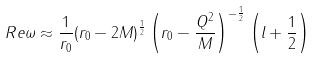Convert formula to latex. <formula><loc_0><loc_0><loc_500><loc_500>R e \omega \approx \frac { 1 } { r _ { 0 } } ( r _ { 0 } - 2 M ) ^ { \frac { 1 } { 2 } } \left ( r _ { 0 } - \frac { Q ^ { 2 } } { M } \right ) ^ { - \frac { 1 } { 2 } } \left ( l + \frac { 1 } { 2 } \right )</formula> 